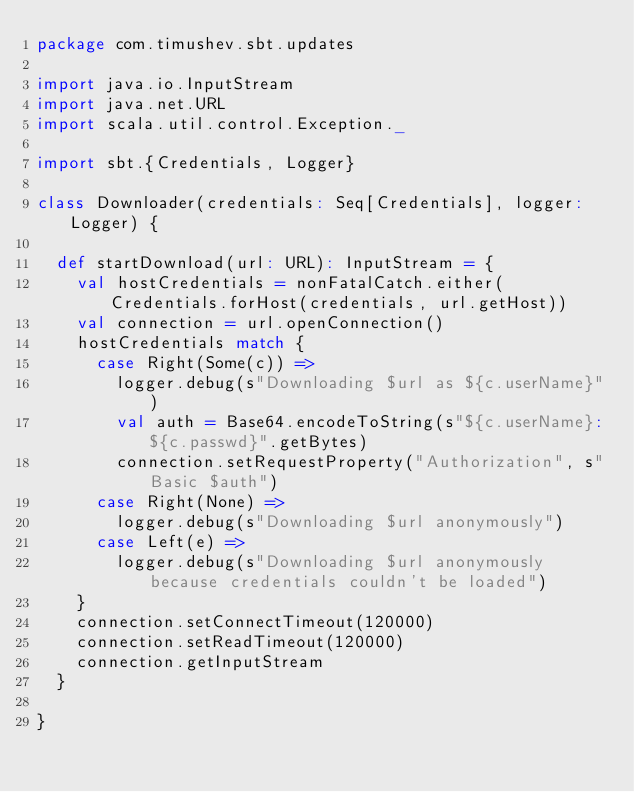<code> <loc_0><loc_0><loc_500><loc_500><_Scala_>package com.timushev.sbt.updates

import java.io.InputStream
import java.net.URL
import scala.util.control.Exception._

import sbt.{Credentials, Logger}

class Downloader(credentials: Seq[Credentials], logger: Logger) {

  def startDownload(url: URL): InputStream = {
    val hostCredentials = nonFatalCatch.either(Credentials.forHost(credentials, url.getHost))
    val connection = url.openConnection()
    hostCredentials match {
      case Right(Some(c)) =>
        logger.debug(s"Downloading $url as ${c.userName}")
        val auth = Base64.encodeToString(s"${c.userName}:${c.passwd}".getBytes)
        connection.setRequestProperty("Authorization", s"Basic $auth")
      case Right(None) =>
        logger.debug(s"Downloading $url anonymously")
      case Left(e) =>
        logger.debug(s"Downloading $url anonymously because credentials couldn't be loaded")
    }
    connection.setConnectTimeout(120000)
    connection.setReadTimeout(120000)
    connection.getInputStream
  }

}
</code> 